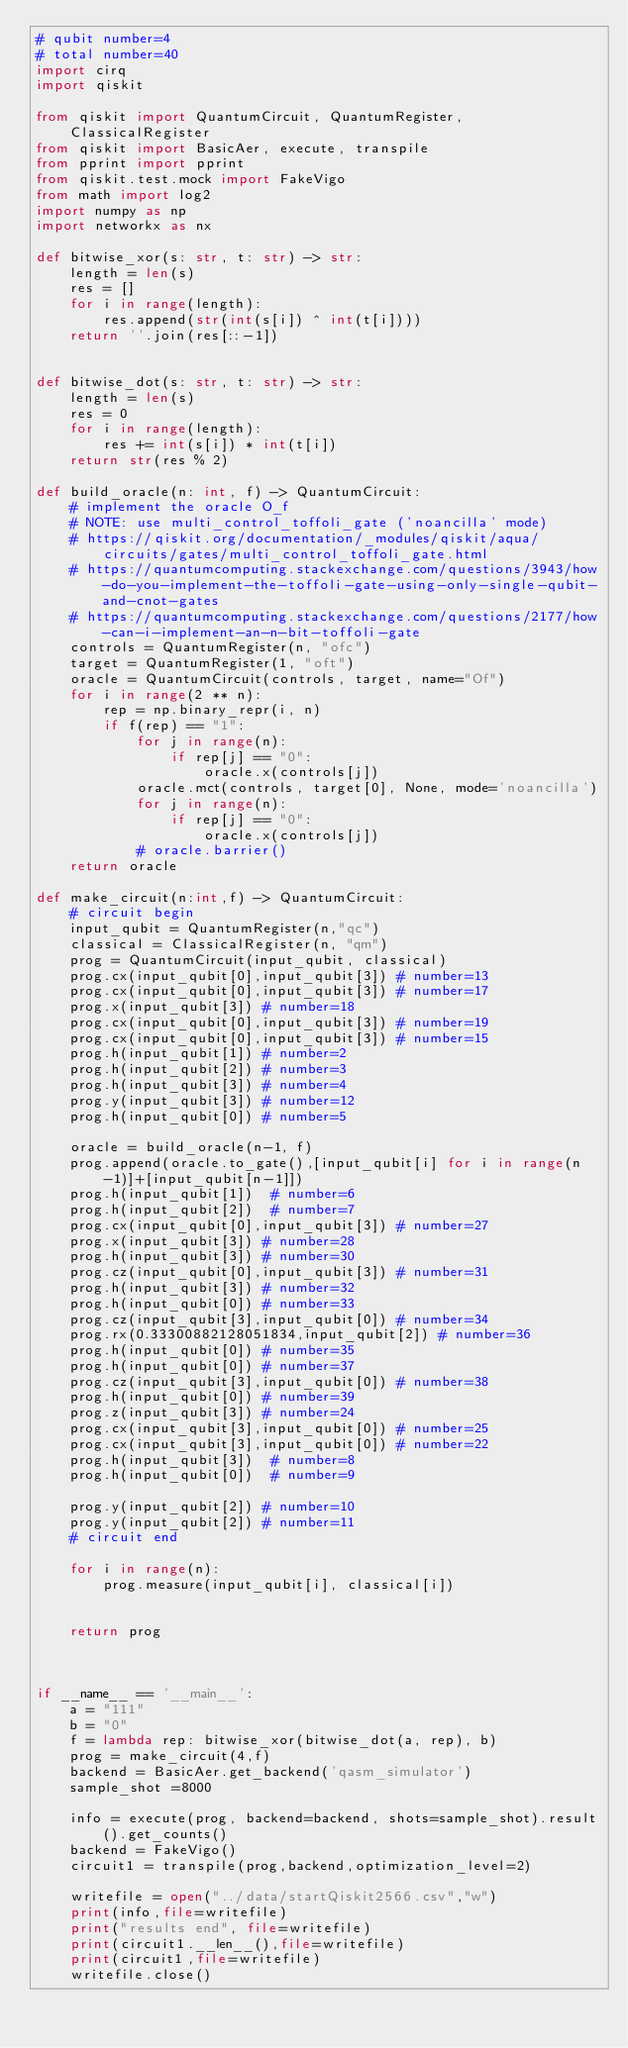<code> <loc_0><loc_0><loc_500><loc_500><_Python_># qubit number=4
# total number=40
import cirq
import qiskit

from qiskit import QuantumCircuit, QuantumRegister, ClassicalRegister
from qiskit import BasicAer, execute, transpile
from pprint import pprint
from qiskit.test.mock import FakeVigo
from math import log2
import numpy as np
import networkx as nx

def bitwise_xor(s: str, t: str) -> str:
    length = len(s)
    res = []
    for i in range(length):
        res.append(str(int(s[i]) ^ int(t[i])))
    return ''.join(res[::-1])


def bitwise_dot(s: str, t: str) -> str:
    length = len(s)
    res = 0
    for i in range(length):
        res += int(s[i]) * int(t[i])
    return str(res % 2)

def build_oracle(n: int, f) -> QuantumCircuit:
    # implement the oracle O_f
    # NOTE: use multi_control_toffoli_gate ('noancilla' mode)
    # https://qiskit.org/documentation/_modules/qiskit/aqua/circuits/gates/multi_control_toffoli_gate.html
    # https://quantumcomputing.stackexchange.com/questions/3943/how-do-you-implement-the-toffoli-gate-using-only-single-qubit-and-cnot-gates
    # https://quantumcomputing.stackexchange.com/questions/2177/how-can-i-implement-an-n-bit-toffoli-gate
    controls = QuantumRegister(n, "ofc")
    target = QuantumRegister(1, "oft")
    oracle = QuantumCircuit(controls, target, name="Of")
    for i in range(2 ** n):
        rep = np.binary_repr(i, n)
        if f(rep) == "1":
            for j in range(n):
                if rep[j] == "0":
                    oracle.x(controls[j])
            oracle.mct(controls, target[0], None, mode='noancilla')
            for j in range(n):
                if rep[j] == "0":
                    oracle.x(controls[j])
            # oracle.barrier()
    return oracle

def make_circuit(n:int,f) -> QuantumCircuit:
    # circuit begin
    input_qubit = QuantumRegister(n,"qc")
    classical = ClassicalRegister(n, "qm")
    prog = QuantumCircuit(input_qubit, classical)
    prog.cx(input_qubit[0],input_qubit[3]) # number=13
    prog.cx(input_qubit[0],input_qubit[3]) # number=17
    prog.x(input_qubit[3]) # number=18
    prog.cx(input_qubit[0],input_qubit[3]) # number=19
    prog.cx(input_qubit[0],input_qubit[3]) # number=15
    prog.h(input_qubit[1]) # number=2
    prog.h(input_qubit[2]) # number=3
    prog.h(input_qubit[3]) # number=4
    prog.y(input_qubit[3]) # number=12
    prog.h(input_qubit[0]) # number=5

    oracle = build_oracle(n-1, f)
    prog.append(oracle.to_gate(),[input_qubit[i] for i in range(n-1)]+[input_qubit[n-1]])
    prog.h(input_qubit[1])  # number=6
    prog.h(input_qubit[2])  # number=7
    prog.cx(input_qubit[0],input_qubit[3]) # number=27
    prog.x(input_qubit[3]) # number=28
    prog.h(input_qubit[3]) # number=30
    prog.cz(input_qubit[0],input_qubit[3]) # number=31
    prog.h(input_qubit[3]) # number=32
    prog.h(input_qubit[0]) # number=33
    prog.cz(input_qubit[3],input_qubit[0]) # number=34
    prog.rx(0.33300882128051834,input_qubit[2]) # number=36
    prog.h(input_qubit[0]) # number=35
    prog.h(input_qubit[0]) # number=37
    prog.cz(input_qubit[3],input_qubit[0]) # number=38
    prog.h(input_qubit[0]) # number=39
    prog.z(input_qubit[3]) # number=24
    prog.cx(input_qubit[3],input_qubit[0]) # number=25
    prog.cx(input_qubit[3],input_qubit[0]) # number=22
    prog.h(input_qubit[3])  # number=8
    prog.h(input_qubit[0])  # number=9

    prog.y(input_qubit[2]) # number=10
    prog.y(input_qubit[2]) # number=11
    # circuit end

    for i in range(n):
        prog.measure(input_qubit[i], classical[i])


    return prog



if __name__ == '__main__':
    a = "111"
    b = "0"
    f = lambda rep: bitwise_xor(bitwise_dot(a, rep), b)
    prog = make_circuit(4,f)
    backend = BasicAer.get_backend('qasm_simulator')
    sample_shot =8000

    info = execute(prog, backend=backend, shots=sample_shot).result().get_counts()
    backend = FakeVigo()
    circuit1 = transpile(prog,backend,optimization_level=2)

    writefile = open("../data/startQiskit2566.csv","w")
    print(info,file=writefile)
    print("results end", file=writefile)
    print(circuit1.__len__(),file=writefile)
    print(circuit1,file=writefile)
    writefile.close()
</code> 